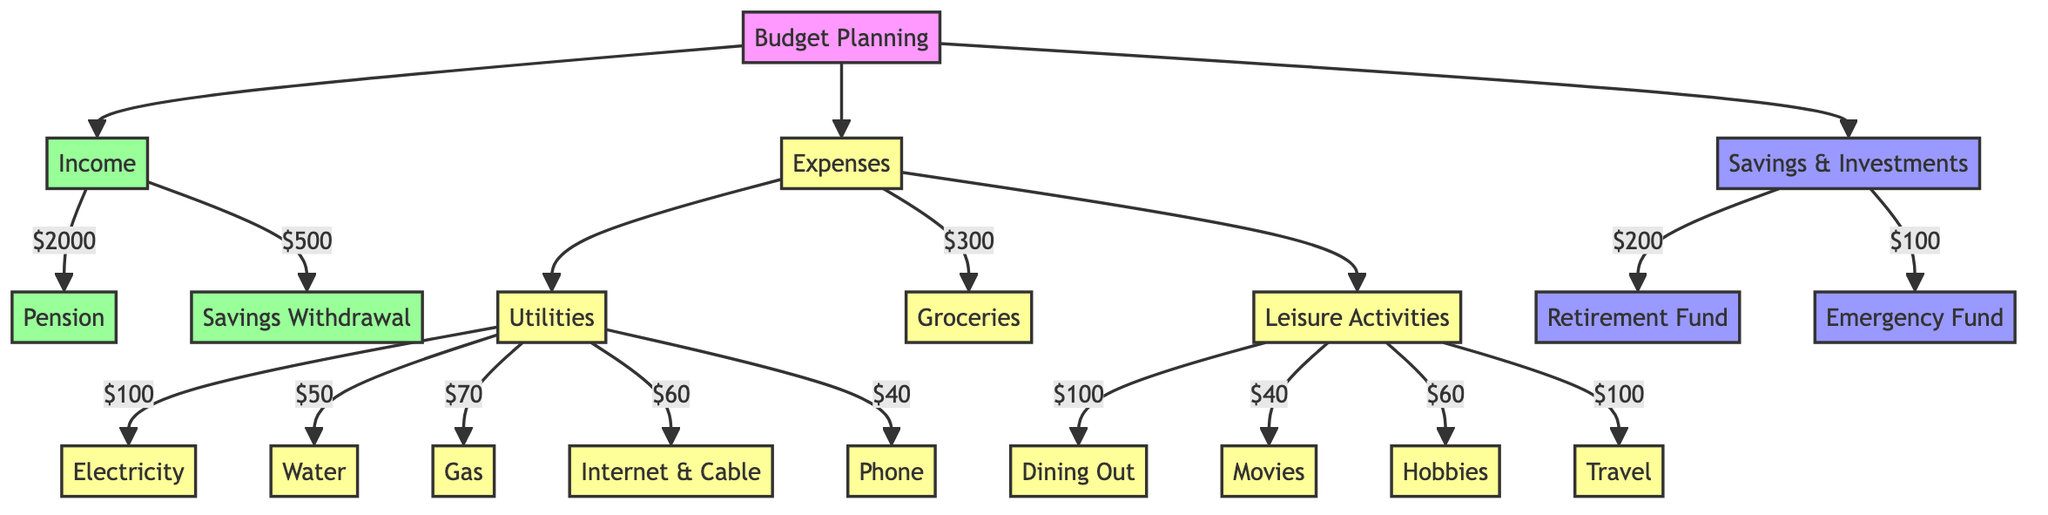What is the total income? The total income is calculated by adding the pension and savings withdrawal. The pension is $2000, and the savings withdrawal is $500, so $2000 + $500 = $2500.
Answer: $2500 How much is spent on leisure activities? The total spent on leisure activities can be found by summing all the components: Dining Out ($100) + Movies ($40) + Hobbies ($60) + Travel ($100) = $300.
Answer: $300 Which utility is the most expensive? To find the most expensive utility, we compare the values of Electricity ($100), Water ($50), Gas ($70), Internet and Cable ($60), and Phone ($40). The highest value is Electricity at $100.
Answer: Electricity What is the total amount allocated to savings and investments? The total for savings and investments is derived from Retirement Fund Contribution ($200) plus Emergency Fund ($100), which equals $300.
Answer: $300 What portion of the income is spent on utilities? The portion spent on utilities is the total expense for utilities divided by the total income. Total utilities = Electricity ($100) + Water ($50) + Gas ($70) + Internet and Cable ($60) + Phone ($40) = $320. Therefore, $320 is spent out of $2500 income.
Answer: $320 How many components are in the expenses section? The components of the expenses section can be counted: there are Utilities (5 components), Groceries (1), and Leisure Activities (4). Adding these gives 5 + 1 + 4 = 10 components in total.
Answer: 10 What is the total spent on utilities compared to the groceries? For this comparison, we first calculate the total spent on utilities ($320). Then we take the amount spent on groceries, which is $300. Comparing the two, we see that utilities are $20 more expensive than groceries.
Answer: $20 What is the total spending on groceries and leisure activities combined? To find the combined spending, we sum the groceries ($300) and the leisure activities ($300) together. Thus, $300 + $300 = $600 is the total.
Answer: $600 Which savings category has a higher allocation? We compare the two categories of savings: Retirement Fund Contribution ($200) and Emergency Fund ($100). Since $200 is greater than $100, the Retirement Fund Contribution has a higher allocation.
Answer: Retirement Fund Contribution 